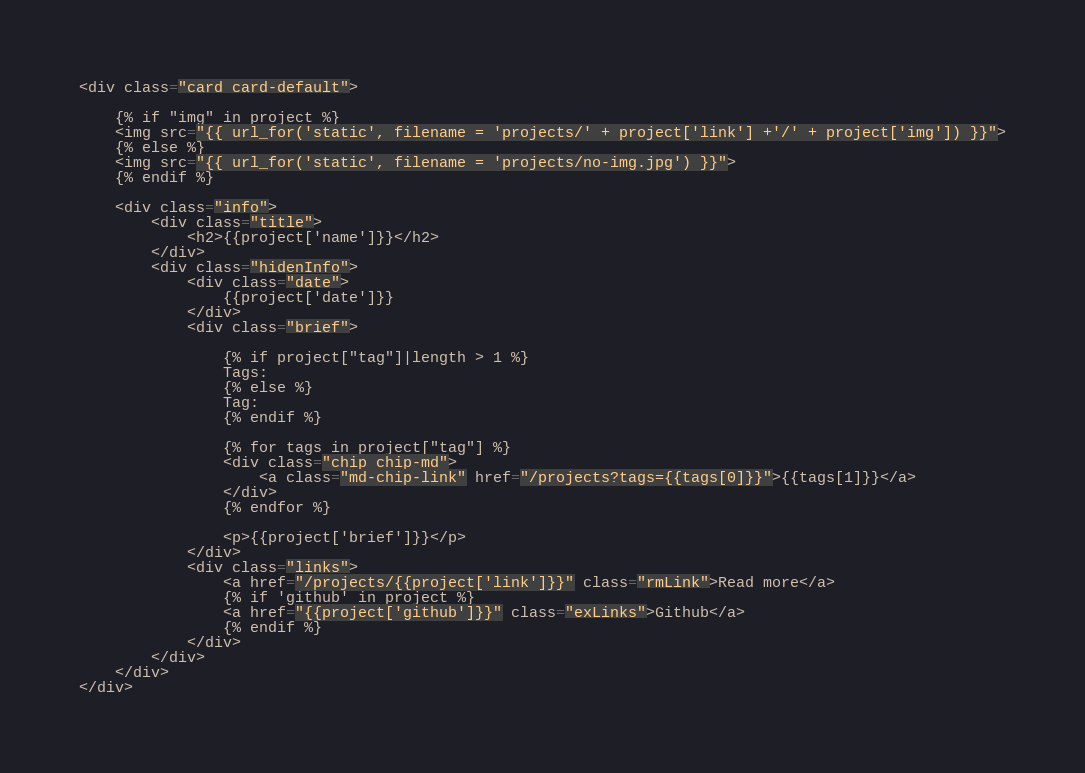<code> <loc_0><loc_0><loc_500><loc_500><_HTML_><div class="card card-default">

    {% if "img" in project %}
    <img src="{{ url_for('static', filename = 'projects/' + project['link'] +'/' + project['img']) }}">
    {% else %}
    <img src="{{ url_for('static', filename = 'projects/no-img.jpg') }}">
    {% endif %}

    <div class="info">
        <div class="title">
            <h2>{{project['name']}}</h2>
        </div>
        <div class="hidenInfo">
            <div class="date">
                {{project['date']}}
            </div>
            <div class="brief">

                {% if project["tag"]|length > 1 %}
                Tags:
                {% else %}
                Tag:
                {% endif %}

                {% for tags in project["tag"] %}
                <div class="chip chip-md">
                    <a class="md-chip-link" href="/projects?tags={{tags[0]}}">{{tags[1]}}</a>
                </div>
                {% endfor %}

                <p>{{project['brief']}}</p>
            </div>
            <div class="links">
                <a href="/projects/{{project['link']}}" class="rmLink">Read more</a>
                {% if 'github' in project %}
                <a href="{{project['github']}}" class="exLinks">Github</a>
                {% endif %}
            </div>
        </div>
    </div>
</div></code> 